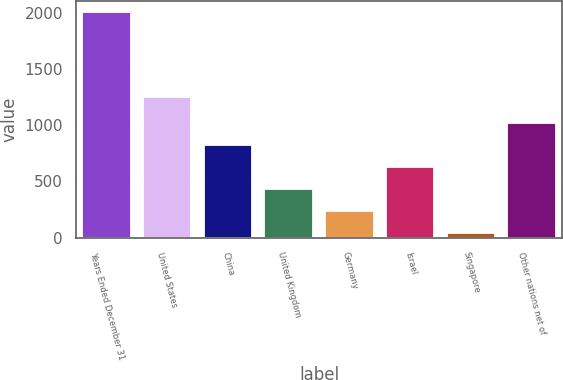<chart> <loc_0><loc_0><loc_500><loc_500><bar_chart><fcel>Years Ended December 31<fcel>United States<fcel>China<fcel>United Kingdom<fcel>Germany<fcel>Israel<fcel>Singapore<fcel>Other nations net of<nl><fcel>2007<fcel>1252<fcel>826.8<fcel>433.4<fcel>236.7<fcel>630.1<fcel>40<fcel>1023.5<nl></chart> 